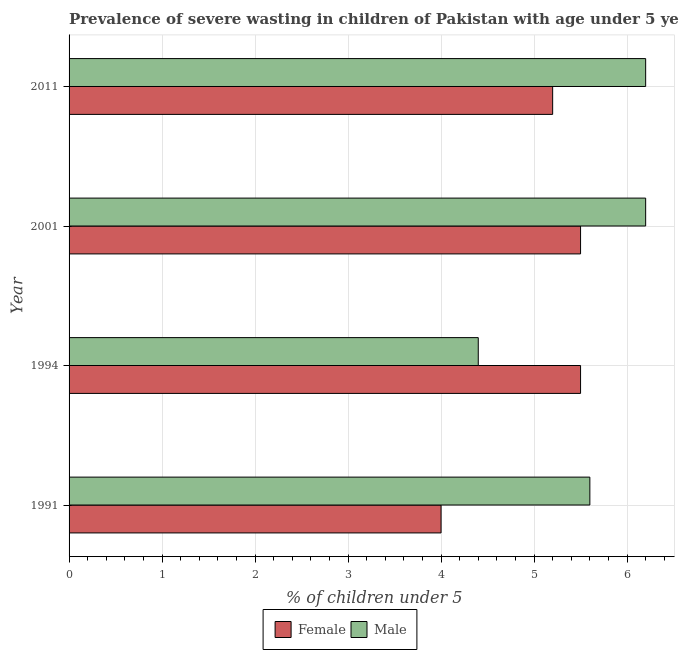How many groups of bars are there?
Make the answer very short. 4. Are the number of bars per tick equal to the number of legend labels?
Offer a very short reply. Yes. Are the number of bars on each tick of the Y-axis equal?
Ensure brevity in your answer.  Yes. How many bars are there on the 3rd tick from the top?
Your response must be concise. 2. What is the label of the 1st group of bars from the top?
Offer a very short reply. 2011. In how many cases, is the number of bars for a given year not equal to the number of legend labels?
Offer a very short reply. 0. What is the percentage of undernourished male children in 1994?
Provide a succinct answer. 4.4. In which year was the percentage of undernourished male children maximum?
Your answer should be compact. 2001. In which year was the percentage of undernourished female children minimum?
Make the answer very short. 1991. What is the total percentage of undernourished female children in the graph?
Provide a short and direct response. 20.2. What is the difference between the percentage of undernourished female children in 2011 and the percentage of undernourished male children in 2001?
Make the answer very short. -1. What is the average percentage of undernourished female children per year?
Offer a very short reply. 5.05. In the year 1991, what is the difference between the percentage of undernourished female children and percentage of undernourished male children?
Offer a very short reply. -1.6. In how many years, is the percentage of undernourished male children greater than 1.4 %?
Offer a terse response. 4. What is the ratio of the percentage of undernourished male children in 1994 to that in 2011?
Ensure brevity in your answer.  0.71. What is the difference between the highest and the second highest percentage of undernourished female children?
Give a very brief answer. 0. What is the difference between the highest and the lowest percentage of undernourished male children?
Offer a very short reply. 1.8. In how many years, is the percentage of undernourished male children greater than the average percentage of undernourished male children taken over all years?
Offer a terse response. 3. What does the 2nd bar from the top in 2011 represents?
Keep it short and to the point. Female. Are all the bars in the graph horizontal?
Keep it short and to the point. Yes. How many years are there in the graph?
Keep it short and to the point. 4. Does the graph contain any zero values?
Your answer should be very brief. No. Where does the legend appear in the graph?
Provide a short and direct response. Bottom center. How are the legend labels stacked?
Keep it short and to the point. Horizontal. What is the title of the graph?
Give a very brief answer. Prevalence of severe wasting in children of Pakistan with age under 5 years. Does "Age 15+" appear as one of the legend labels in the graph?
Your response must be concise. No. What is the label or title of the X-axis?
Provide a succinct answer.  % of children under 5. What is the  % of children under 5 in Female in 1991?
Give a very brief answer. 4. What is the  % of children under 5 of Male in 1991?
Ensure brevity in your answer.  5.6. What is the  % of children under 5 in Male in 1994?
Give a very brief answer. 4.4. What is the  % of children under 5 in Female in 2001?
Provide a short and direct response. 5.5. What is the  % of children under 5 in Male in 2001?
Give a very brief answer. 6.2. What is the  % of children under 5 of Female in 2011?
Offer a terse response. 5.2. What is the  % of children under 5 in Male in 2011?
Your answer should be very brief. 6.2. Across all years, what is the maximum  % of children under 5 in Male?
Keep it short and to the point. 6.2. Across all years, what is the minimum  % of children under 5 of Female?
Provide a succinct answer. 4. Across all years, what is the minimum  % of children under 5 of Male?
Provide a succinct answer. 4.4. What is the total  % of children under 5 of Female in the graph?
Give a very brief answer. 20.2. What is the total  % of children under 5 of Male in the graph?
Offer a terse response. 22.4. What is the difference between the  % of children under 5 of Female in 1991 and that in 1994?
Ensure brevity in your answer.  -1.5. What is the difference between the  % of children under 5 in Male in 1991 and that in 1994?
Your answer should be very brief. 1.2. What is the difference between the  % of children under 5 of Female in 1991 and that in 2011?
Your response must be concise. -1.2. What is the difference between the  % of children under 5 in Male in 1991 and that in 2011?
Give a very brief answer. -0.6. What is the difference between the  % of children under 5 in Male in 1994 and that in 2001?
Offer a very short reply. -1.8. What is the difference between the  % of children under 5 of Female in 1994 and that in 2011?
Your answer should be very brief. 0.3. What is the difference between the  % of children under 5 of Male in 1994 and that in 2011?
Provide a short and direct response. -1.8. What is the difference between the  % of children under 5 of Male in 2001 and that in 2011?
Your answer should be very brief. 0. What is the difference between the  % of children under 5 of Female in 1991 and the  % of children under 5 of Male in 1994?
Your answer should be very brief. -0.4. What is the difference between the  % of children under 5 in Female in 1991 and the  % of children under 5 in Male in 2011?
Offer a very short reply. -2.2. What is the difference between the  % of children under 5 of Female in 1994 and the  % of children under 5 of Male in 2001?
Your response must be concise. -0.7. What is the average  % of children under 5 in Female per year?
Provide a succinct answer. 5.05. In the year 1991, what is the difference between the  % of children under 5 in Female and  % of children under 5 in Male?
Offer a terse response. -1.6. In the year 1994, what is the difference between the  % of children under 5 of Female and  % of children under 5 of Male?
Provide a short and direct response. 1.1. In the year 2011, what is the difference between the  % of children under 5 in Female and  % of children under 5 in Male?
Keep it short and to the point. -1. What is the ratio of the  % of children under 5 in Female in 1991 to that in 1994?
Your response must be concise. 0.73. What is the ratio of the  % of children under 5 of Male in 1991 to that in 1994?
Ensure brevity in your answer.  1.27. What is the ratio of the  % of children under 5 in Female in 1991 to that in 2001?
Offer a terse response. 0.73. What is the ratio of the  % of children under 5 of Male in 1991 to that in 2001?
Ensure brevity in your answer.  0.9. What is the ratio of the  % of children under 5 of Female in 1991 to that in 2011?
Make the answer very short. 0.77. What is the ratio of the  % of children under 5 in Male in 1991 to that in 2011?
Your answer should be very brief. 0.9. What is the ratio of the  % of children under 5 of Female in 1994 to that in 2001?
Your response must be concise. 1. What is the ratio of the  % of children under 5 of Male in 1994 to that in 2001?
Your response must be concise. 0.71. What is the ratio of the  % of children under 5 in Female in 1994 to that in 2011?
Your answer should be compact. 1.06. What is the ratio of the  % of children under 5 in Male in 1994 to that in 2011?
Your answer should be very brief. 0.71. What is the ratio of the  % of children under 5 in Female in 2001 to that in 2011?
Your response must be concise. 1.06. 